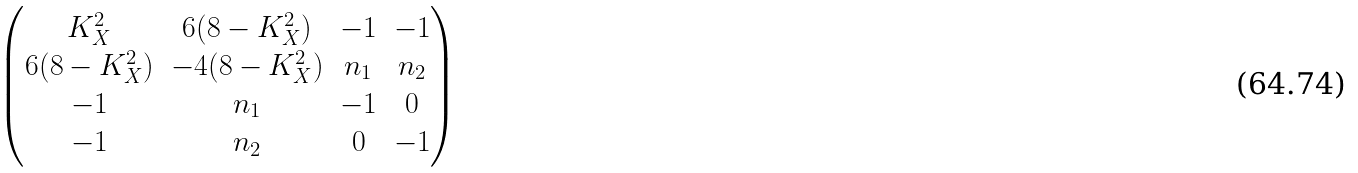<formula> <loc_0><loc_0><loc_500><loc_500>\begin{pmatrix} K _ { X } ^ { 2 } & 6 ( 8 - K _ { X } ^ { 2 } ) & - 1 & - 1 \\ 6 ( 8 - K _ { X } ^ { 2 } ) & - 4 ( 8 - K _ { X } ^ { 2 } ) & n _ { 1 } & n _ { 2 } \\ - 1 & n _ { 1 } & - 1 & 0 \\ - 1 & n _ { 2 } & 0 & - 1 \end{pmatrix}</formula> 